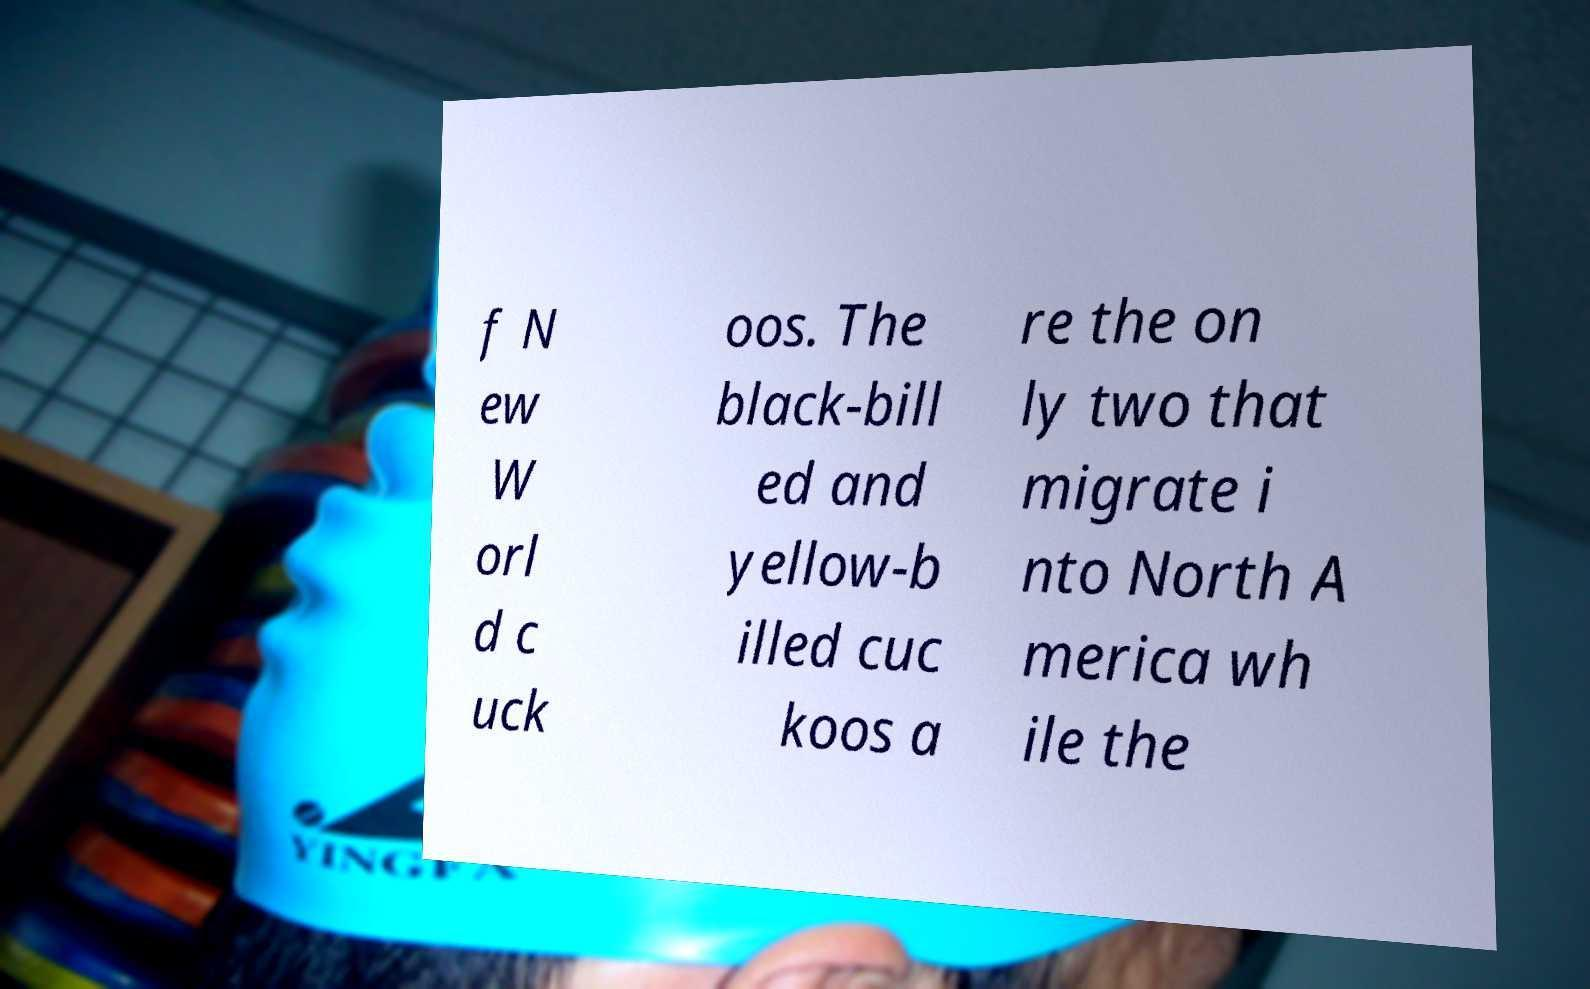Please identify and transcribe the text found in this image. f N ew W orl d c uck oos. The black-bill ed and yellow-b illed cuc koos a re the on ly two that migrate i nto North A merica wh ile the 